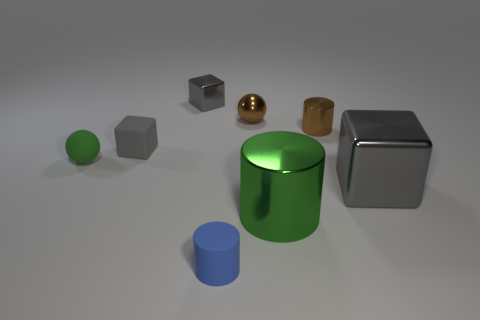What could be the purpose of this arrangement of shapes? The arrangement seems to be a demonstration of 3D modeling and rendering techniques. It may serve as an exercise to showcase how lighting and shadows interact with different geometrical shapes and materials in a simulated environment. 